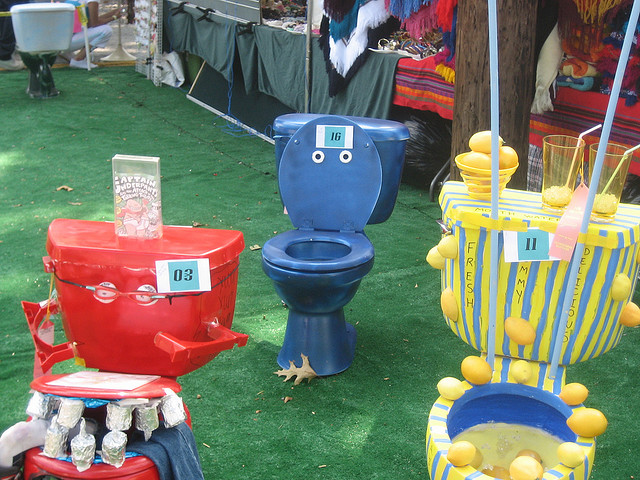Please transcribe the text in this image. 03 16 11 133 FRESH APTAIN 